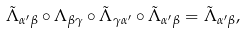<formula> <loc_0><loc_0><loc_500><loc_500>\tilde { \Lambda } _ { \alpha ^ { \prime } \beta } \circ \Lambda _ { \beta \gamma } \circ \tilde { \Lambda } _ { \gamma \alpha ^ { \prime } } \circ \tilde { \Lambda } _ { \alpha ^ { \prime } \beta } = \tilde { \Lambda } _ { \alpha ^ { \prime } \beta } ,</formula> 